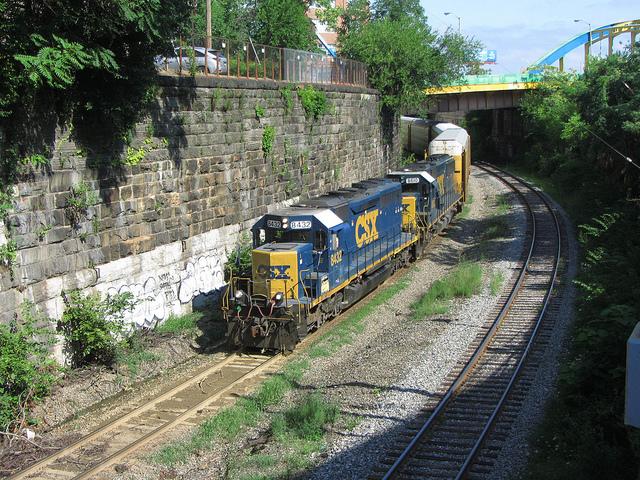What letter is on the train?
Quick response, please. Csx. What is to the left of the train?
Quick response, please. Wall. What is on the right side of the train?
Keep it brief. Wall. What color is the car in the picture?
Quick response, please. Silver. What color is the train?
Keep it brief. Blue and yellow. Why are the tracks below street level?
Write a very short answer. Tunnel. How many colors is the train painted?
Answer briefly. 3. Is this a rural scene?
Be succinct. Yes. Is this train track laid on the ground or on a man made structure?
Give a very brief answer. Ground. Is there a train on the tracks?
Concise answer only. Yes. What color is the car coming?
Concise answer only. Blue. 